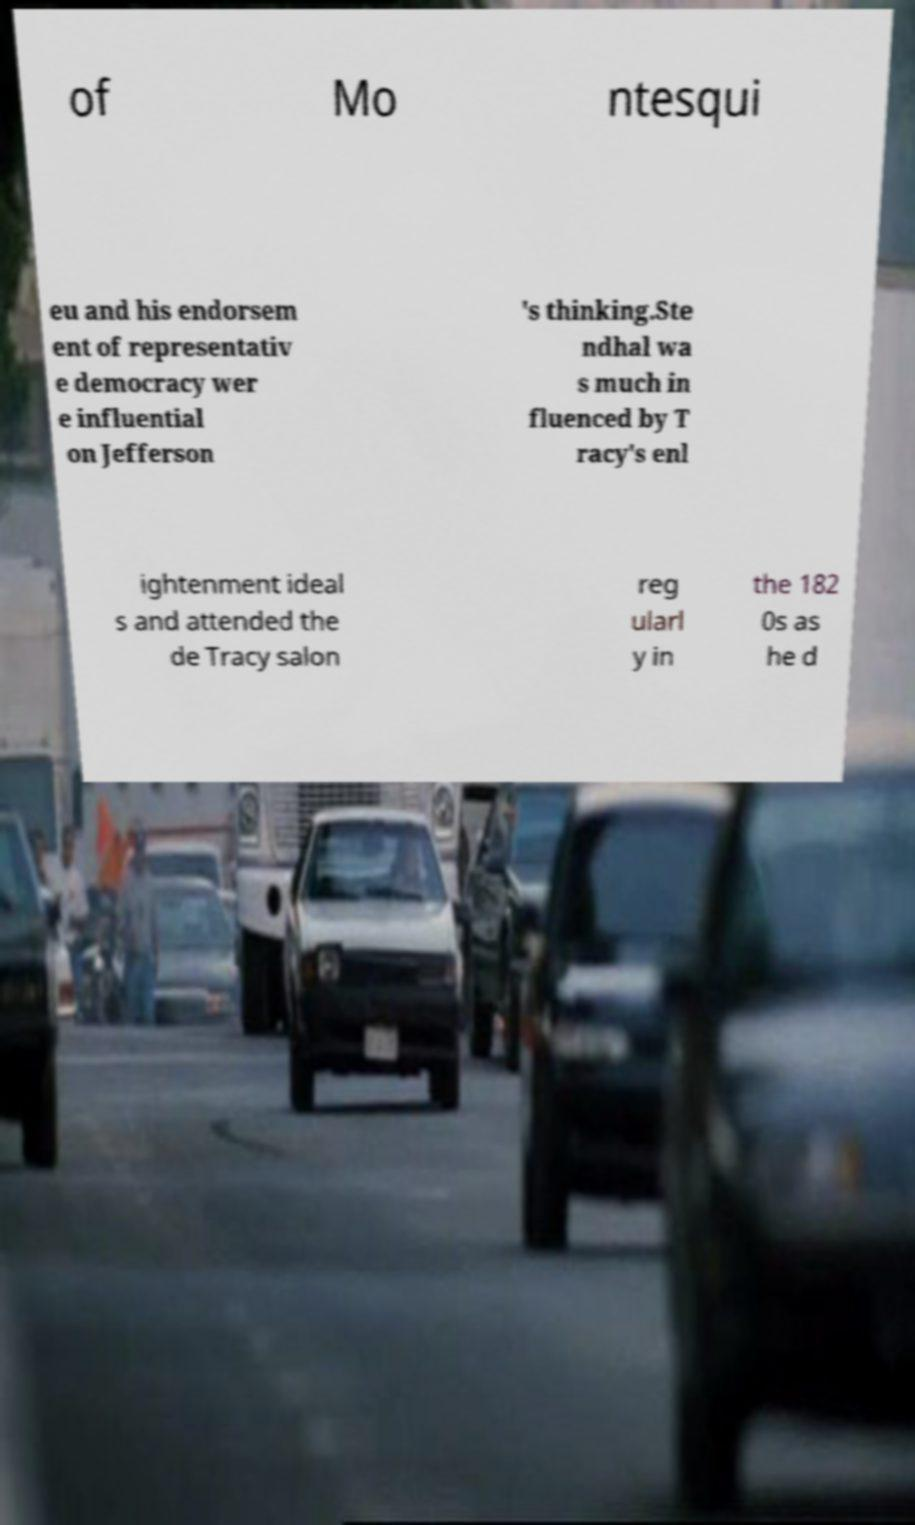I need the written content from this picture converted into text. Can you do that? of Mo ntesqui eu and his endorsem ent of representativ e democracy wer e influential on Jefferson 's thinking.Ste ndhal wa s much in fluenced by T racy's enl ightenment ideal s and attended the de Tracy salon reg ularl y in the 182 0s as he d 